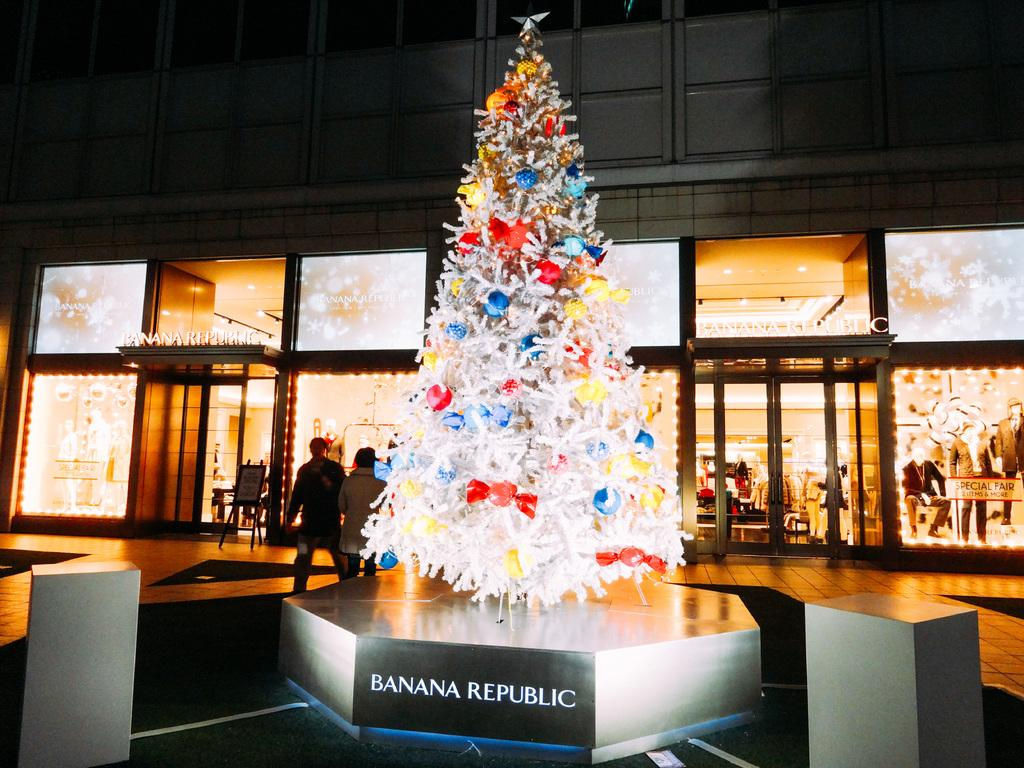What is the main subject of the image? The main subject of the image is a tree with gifts tied to it on a platform. What can be seen in the background of the image? In the background, there is a building, doors, lights, dresses, and other unspecified objects. Are there any people visible in the image? Yes, two persons are walking on the road in the background. What type of acoustics can be heard in the image? There is no information about sounds or acoustics in the image, so it cannot be determined. What government policies are being discussed in the image? There is no indication of any discussion or policy in the image. 